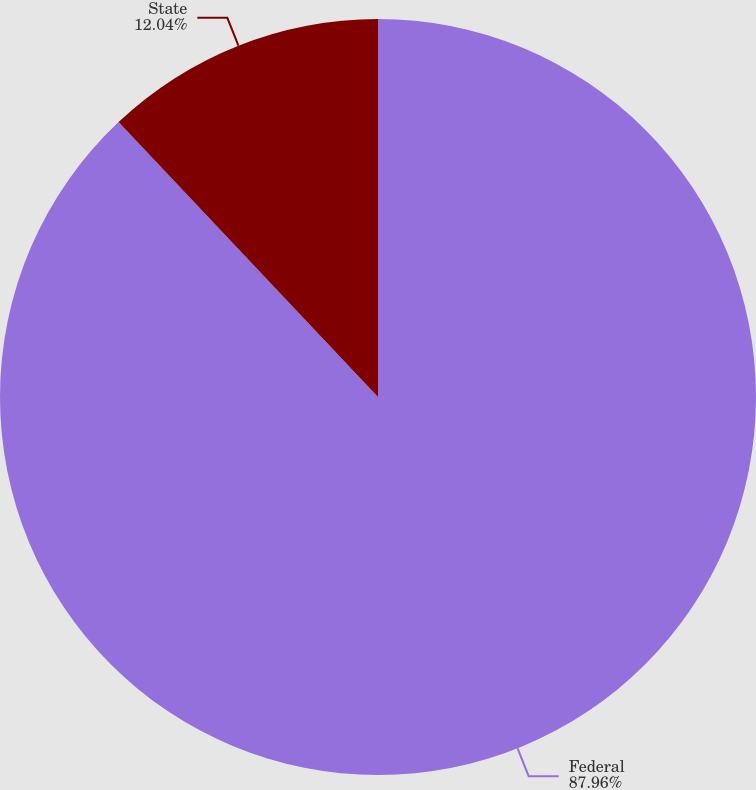<chart> <loc_0><loc_0><loc_500><loc_500><pie_chart><fcel>Federal<fcel>State<nl><fcel>87.96%<fcel>12.04%<nl></chart> 